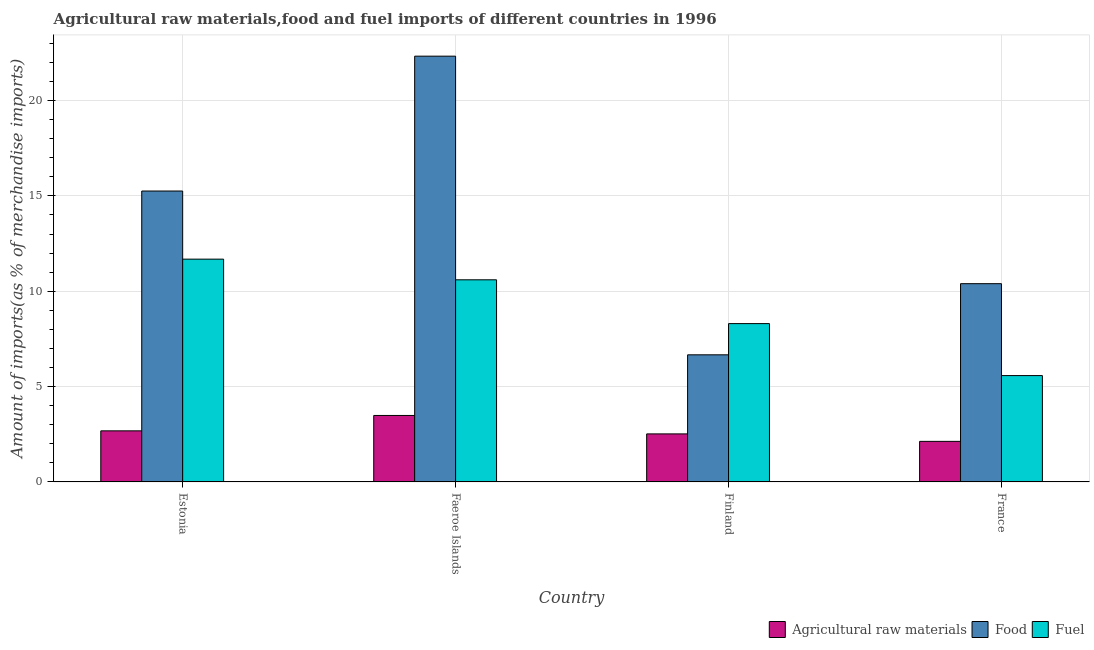How many different coloured bars are there?
Ensure brevity in your answer.  3. How many groups of bars are there?
Offer a very short reply. 4. How many bars are there on the 2nd tick from the left?
Make the answer very short. 3. How many bars are there on the 1st tick from the right?
Make the answer very short. 3. What is the label of the 3rd group of bars from the left?
Offer a terse response. Finland. What is the percentage of food imports in Faeroe Islands?
Offer a very short reply. 22.33. Across all countries, what is the maximum percentage of raw materials imports?
Provide a succinct answer. 3.48. Across all countries, what is the minimum percentage of raw materials imports?
Your response must be concise. 2.13. In which country was the percentage of raw materials imports maximum?
Provide a short and direct response. Faeroe Islands. In which country was the percentage of raw materials imports minimum?
Give a very brief answer. France. What is the total percentage of fuel imports in the graph?
Keep it short and to the point. 36.16. What is the difference between the percentage of raw materials imports in Estonia and that in France?
Offer a terse response. 0.55. What is the difference between the percentage of food imports in Faeroe Islands and the percentage of fuel imports in Finland?
Provide a short and direct response. 14.02. What is the average percentage of food imports per country?
Offer a terse response. 13.66. What is the difference between the percentage of raw materials imports and percentage of food imports in Estonia?
Offer a very short reply. -12.58. In how many countries, is the percentage of fuel imports greater than 13 %?
Make the answer very short. 0. What is the ratio of the percentage of raw materials imports in Finland to that in France?
Your answer should be compact. 1.18. Is the percentage of fuel imports in Estonia less than that in Finland?
Give a very brief answer. No. What is the difference between the highest and the second highest percentage of food imports?
Offer a very short reply. 7.07. What is the difference between the highest and the lowest percentage of food imports?
Your answer should be compact. 15.66. In how many countries, is the percentage of fuel imports greater than the average percentage of fuel imports taken over all countries?
Offer a very short reply. 2. Is the sum of the percentage of fuel imports in Estonia and France greater than the maximum percentage of raw materials imports across all countries?
Keep it short and to the point. Yes. What does the 2nd bar from the left in Estonia represents?
Your answer should be very brief. Food. What does the 2nd bar from the right in Finland represents?
Make the answer very short. Food. Is it the case that in every country, the sum of the percentage of raw materials imports and percentage of food imports is greater than the percentage of fuel imports?
Provide a succinct answer. Yes. How many bars are there?
Your answer should be very brief. 12. How many countries are there in the graph?
Offer a terse response. 4. Are the values on the major ticks of Y-axis written in scientific E-notation?
Your answer should be very brief. No. Does the graph contain any zero values?
Your response must be concise. No. Does the graph contain grids?
Your response must be concise. Yes. Where does the legend appear in the graph?
Ensure brevity in your answer.  Bottom right. How many legend labels are there?
Offer a very short reply. 3. How are the legend labels stacked?
Keep it short and to the point. Horizontal. What is the title of the graph?
Provide a succinct answer. Agricultural raw materials,food and fuel imports of different countries in 1996. Does "Social Protection and Labor" appear as one of the legend labels in the graph?
Ensure brevity in your answer.  No. What is the label or title of the Y-axis?
Provide a succinct answer. Amount of imports(as % of merchandise imports). What is the Amount of imports(as % of merchandise imports) in Agricultural raw materials in Estonia?
Give a very brief answer. 2.68. What is the Amount of imports(as % of merchandise imports) of Food in Estonia?
Offer a terse response. 15.25. What is the Amount of imports(as % of merchandise imports) in Fuel in Estonia?
Give a very brief answer. 11.68. What is the Amount of imports(as % of merchandise imports) in Agricultural raw materials in Faeroe Islands?
Keep it short and to the point. 3.48. What is the Amount of imports(as % of merchandise imports) of Food in Faeroe Islands?
Give a very brief answer. 22.33. What is the Amount of imports(as % of merchandise imports) in Fuel in Faeroe Islands?
Provide a short and direct response. 10.6. What is the Amount of imports(as % of merchandise imports) of Agricultural raw materials in Finland?
Your answer should be compact. 2.52. What is the Amount of imports(as % of merchandise imports) in Food in Finland?
Your answer should be compact. 6.66. What is the Amount of imports(as % of merchandise imports) in Fuel in Finland?
Provide a short and direct response. 8.3. What is the Amount of imports(as % of merchandise imports) in Agricultural raw materials in France?
Your answer should be compact. 2.13. What is the Amount of imports(as % of merchandise imports) of Food in France?
Ensure brevity in your answer.  10.39. What is the Amount of imports(as % of merchandise imports) in Fuel in France?
Offer a terse response. 5.58. Across all countries, what is the maximum Amount of imports(as % of merchandise imports) in Agricultural raw materials?
Keep it short and to the point. 3.48. Across all countries, what is the maximum Amount of imports(as % of merchandise imports) of Food?
Your answer should be compact. 22.33. Across all countries, what is the maximum Amount of imports(as % of merchandise imports) of Fuel?
Your response must be concise. 11.68. Across all countries, what is the minimum Amount of imports(as % of merchandise imports) of Agricultural raw materials?
Your response must be concise. 2.13. Across all countries, what is the minimum Amount of imports(as % of merchandise imports) of Food?
Your answer should be very brief. 6.66. Across all countries, what is the minimum Amount of imports(as % of merchandise imports) of Fuel?
Give a very brief answer. 5.58. What is the total Amount of imports(as % of merchandise imports) of Agricultural raw materials in the graph?
Make the answer very short. 10.81. What is the total Amount of imports(as % of merchandise imports) in Food in the graph?
Make the answer very short. 54.64. What is the total Amount of imports(as % of merchandise imports) in Fuel in the graph?
Your answer should be very brief. 36.16. What is the difference between the Amount of imports(as % of merchandise imports) of Agricultural raw materials in Estonia and that in Faeroe Islands?
Make the answer very short. -0.81. What is the difference between the Amount of imports(as % of merchandise imports) in Food in Estonia and that in Faeroe Islands?
Keep it short and to the point. -7.07. What is the difference between the Amount of imports(as % of merchandise imports) of Fuel in Estonia and that in Faeroe Islands?
Provide a succinct answer. 1.08. What is the difference between the Amount of imports(as % of merchandise imports) of Agricultural raw materials in Estonia and that in Finland?
Ensure brevity in your answer.  0.16. What is the difference between the Amount of imports(as % of merchandise imports) in Food in Estonia and that in Finland?
Keep it short and to the point. 8.59. What is the difference between the Amount of imports(as % of merchandise imports) of Fuel in Estonia and that in Finland?
Keep it short and to the point. 3.38. What is the difference between the Amount of imports(as % of merchandise imports) in Agricultural raw materials in Estonia and that in France?
Give a very brief answer. 0.55. What is the difference between the Amount of imports(as % of merchandise imports) of Food in Estonia and that in France?
Your answer should be compact. 4.86. What is the difference between the Amount of imports(as % of merchandise imports) of Fuel in Estonia and that in France?
Give a very brief answer. 6.11. What is the difference between the Amount of imports(as % of merchandise imports) in Agricultural raw materials in Faeroe Islands and that in Finland?
Provide a short and direct response. 0.97. What is the difference between the Amount of imports(as % of merchandise imports) in Food in Faeroe Islands and that in Finland?
Your answer should be very brief. 15.66. What is the difference between the Amount of imports(as % of merchandise imports) in Fuel in Faeroe Islands and that in Finland?
Your answer should be compact. 2.3. What is the difference between the Amount of imports(as % of merchandise imports) in Agricultural raw materials in Faeroe Islands and that in France?
Keep it short and to the point. 1.36. What is the difference between the Amount of imports(as % of merchandise imports) of Food in Faeroe Islands and that in France?
Make the answer very short. 11.93. What is the difference between the Amount of imports(as % of merchandise imports) of Fuel in Faeroe Islands and that in France?
Your answer should be very brief. 5.02. What is the difference between the Amount of imports(as % of merchandise imports) of Agricultural raw materials in Finland and that in France?
Your response must be concise. 0.39. What is the difference between the Amount of imports(as % of merchandise imports) of Food in Finland and that in France?
Keep it short and to the point. -3.73. What is the difference between the Amount of imports(as % of merchandise imports) in Fuel in Finland and that in France?
Your answer should be very brief. 2.73. What is the difference between the Amount of imports(as % of merchandise imports) in Agricultural raw materials in Estonia and the Amount of imports(as % of merchandise imports) in Food in Faeroe Islands?
Give a very brief answer. -19.65. What is the difference between the Amount of imports(as % of merchandise imports) of Agricultural raw materials in Estonia and the Amount of imports(as % of merchandise imports) of Fuel in Faeroe Islands?
Keep it short and to the point. -7.92. What is the difference between the Amount of imports(as % of merchandise imports) in Food in Estonia and the Amount of imports(as % of merchandise imports) in Fuel in Faeroe Islands?
Keep it short and to the point. 4.66. What is the difference between the Amount of imports(as % of merchandise imports) in Agricultural raw materials in Estonia and the Amount of imports(as % of merchandise imports) in Food in Finland?
Keep it short and to the point. -3.99. What is the difference between the Amount of imports(as % of merchandise imports) of Agricultural raw materials in Estonia and the Amount of imports(as % of merchandise imports) of Fuel in Finland?
Your response must be concise. -5.62. What is the difference between the Amount of imports(as % of merchandise imports) of Food in Estonia and the Amount of imports(as % of merchandise imports) of Fuel in Finland?
Your answer should be compact. 6.95. What is the difference between the Amount of imports(as % of merchandise imports) in Agricultural raw materials in Estonia and the Amount of imports(as % of merchandise imports) in Food in France?
Your response must be concise. -7.72. What is the difference between the Amount of imports(as % of merchandise imports) of Agricultural raw materials in Estonia and the Amount of imports(as % of merchandise imports) of Fuel in France?
Offer a terse response. -2.9. What is the difference between the Amount of imports(as % of merchandise imports) in Food in Estonia and the Amount of imports(as % of merchandise imports) in Fuel in France?
Provide a succinct answer. 9.68. What is the difference between the Amount of imports(as % of merchandise imports) in Agricultural raw materials in Faeroe Islands and the Amount of imports(as % of merchandise imports) in Food in Finland?
Give a very brief answer. -3.18. What is the difference between the Amount of imports(as % of merchandise imports) in Agricultural raw materials in Faeroe Islands and the Amount of imports(as % of merchandise imports) in Fuel in Finland?
Give a very brief answer. -4.82. What is the difference between the Amount of imports(as % of merchandise imports) in Food in Faeroe Islands and the Amount of imports(as % of merchandise imports) in Fuel in Finland?
Give a very brief answer. 14.02. What is the difference between the Amount of imports(as % of merchandise imports) of Agricultural raw materials in Faeroe Islands and the Amount of imports(as % of merchandise imports) of Food in France?
Make the answer very short. -6.91. What is the difference between the Amount of imports(as % of merchandise imports) of Agricultural raw materials in Faeroe Islands and the Amount of imports(as % of merchandise imports) of Fuel in France?
Keep it short and to the point. -2.09. What is the difference between the Amount of imports(as % of merchandise imports) of Food in Faeroe Islands and the Amount of imports(as % of merchandise imports) of Fuel in France?
Offer a terse response. 16.75. What is the difference between the Amount of imports(as % of merchandise imports) in Agricultural raw materials in Finland and the Amount of imports(as % of merchandise imports) in Food in France?
Provide a short and direct response. -7.88. What is the difference between the Amount of imports(as % of merchandise imports) in Agricultural raw materials in Finland and the Amount of imports(as % of merchandise imports) in Fuel in France?
Give a very brief answer. -3.06. What is the difference between the Amount of imports(as % of merchandise imports) in Food in Finland and the Amount of imports(as % of merchandise imports) in Fuel in France?
Provide a succinct answer. 1.09. What is the average Amount of imports(as % of merchandise imports) of Agricultural raw materials per country?
Offer a very short reply. 2.7. What is the average Amount of imports(as % of merchandise imports) of Food per country?
Offer a terse response. 13.66. What is the average Amount of imports(as % of merchandise imports) of Fuel per country?
Provide a succinct answer. 9.04. What is the difference between the Amount of imports(as % of merchandise imports) of Agricultural raw materials and Amount of imports(as % of merchandise imports) of Food in Estonia?
Your answer should be compact. -12.58. What is the difference between the Amount of imports(as % of merchandise imports) of Agricultural raw materials and Amount of imports(as % of merchandise imports) of Fuel in Estonia?
Ensure brevity in your answer.  -9. What is the difference between the Amount of imports(as % of merchandise imports) in Food and Amount of imports(as % of merchandise imports) in Fuel in Estonia?
Ensure brevity in your answer.  3.57. What is the difference between the Amount of imports(as % of merchandise imports) in Agricultural raw materials and Amount of imports(as % of merchandise imports) in Food in Faeroe Islands?
Keep it short and to the point. -18.84. What is the difference between the Amount of imports(as % of merchandise imports) in Agricultural raw materials and Amount of imports(as % of merchandise imports) in Fuel in Faeroe Islands?
Offer a terse response. -7.11. What is the difference between the Amount of imports(as % of merchandise imports) in Food and Amount of imports(as % of merchandise imports) in Fuel in Faeroe Islands?
Make the answer very short. 11.73. What is the difference between the Amount of imports(as % of merchandise imports) of Agricultural raw materials and Amount of imports(as % of merchandise imports) of Food in Finland?
Make the answer very short. -4.15. What is the difference between the Amount of imports(as % of merchandise imports) of Agricultural raw materials and Amount of imports(as % of merchandise imports) of Fuel in Finland?
Give a very brief answer. -5.78. What is the difference between the Amount of imports(as % of merchandise imports) of Food and Amount of imports(as % of merchandise imports) of Fuel in Finland?
Make the answer very short. -1.64. What is the difference between the Amount of imports(as % of merchandise imports) of Agricultural raw materials and Amount of imports(as % of merchandise imports) of Food in France?
Make the answer very short. -8.27. What is the difference between the Amount of imports(as % of merchandise imports) in Agricultural raw materials and Amount of imports(as % of merchandise imports) in Fuel in France?
Offer a very short reply. -3.45. What is the difference between the Amount of imports(as % of merchandise imports) in Food and Amount of imports(as % of merchandise imports) in Fuel in France?
Your answer should be very brief. 4.82. What is the ratio of the Amount of imports(as % of merchandise imports) in Agricultural raw materials in Estonia to that in Faeroe Islands?
Offer a terse response. 0.77. What is the ratio of the Amount of imports(as % of merchandise imports) of Food in Estonia to that in Faeroe Islands?
Your response must be concise. 0.68. What is the ratio of the Amount of imports(as % of merchandise imports) in Fuel in Estonia to that in Faeroe Islands?
Give a very brief answer. 1.1. What is the ratio of the Amount of imports(as % of merchandise imports) in Agricultural raw materials in Estonia to that in Finland?
Offer a very short reply. 1.06. What is the ratio of the Amount of imports(as % of merchandise imports) of Food in Estonia to that in Finland?
Give a very brief answer. 2.29. What is the ratio of the Amount of imports(as % of merchandise imports) in Fuel in Estonia to that in Finland?
Offer a very short reply. 1.41. What is the ratio of the Amount of imports(as % of merchandise imports) in Agricultural raw materials in Estonia to that in France?
Provide a short and direct response. 1.26. What is the ratio of the Amount of imports(as % of merchandise imports) in Food in Estonia to that in France?
Your answer should be compact. 1.47. What is the ratio of the Amount of imports(as % of merchandise imports) in Fuel in Estonia to that in France?
Keep it short and to the point. 2.1. What is the ratio of the Amount of imports(as % of merchandise imports) of Agricultural raw materials in Faeroe Islands to that in Finland?
Your answer should be very brief. 1.38. What is the ratio of the Amount of imports(as % of merchandise imports) in Food in Faeroe Islands to that in Finland?
Offer a very short reply. 3.35. What is the ratio of the Amount of imports(as % of merchandise imports) of Fuel in Faeroe Islands to that in Finland?
Keep it short and to the point. 1.28. What is the ratio of the Amount of imports(as % of merchandise imports) in Agricultural raw materials in Faeroe Islands to that in France?
Offer a terse response. 1.64. What is the ratio of the Amount of imports(as % of merchandise imports) of Food in Faeroe Islands to that in France?
Ensure brevity in your answer.  2.15. What is the ratio of the Amount of imports(as % of merchandise imports) of Fuel in Faeroe Islands to that in France?
Provide a short and direct response. 1.9. What is the ratio of the Amount of imports(as % of merchandise imports) of Agricultural raw materials in Finland to that in France?
Ensure brevity in your answer.  1.18. What is the ratio of the Amount of imports(as % of merchandise imports) in Food in Finland to that in France?
Offer a terse response. 0.64. What is the ratio of the Amount of imports(as % of merchandise imports) in Fuel in Finland to that in France?
Keep it short and to the point. 1.49. What is the difference between the highest and the second highest Amount of imports(as % of merchandise imports) of Agricultural raw materials?
Provide a short and direct response. 0.81. What is the difference between the highest and the second highest Amount of imports(as % of merchandise imports) in Food?
Your answer should be very brief. 7.07. What is the difference between the highest and the second highest Amount of imports(as % of merchandise imports) of Fuel?
Ensure brevity in your answer.  1.08. What is the difference between the highest and the lowest Amount of imports(as % of merchandise imports) of Agricultural raw materials?
Offer a terse response. 1.36. What is the difference between the highest and the lowest Amount of imports(as % of merchandise imports) in Food?
Give a very brief answer. 15.66. What is the difference between the highest and the lowest Amount of imports(as % of merchandise imports) of Fuel?
Provide a succinct answer. 6.11. 